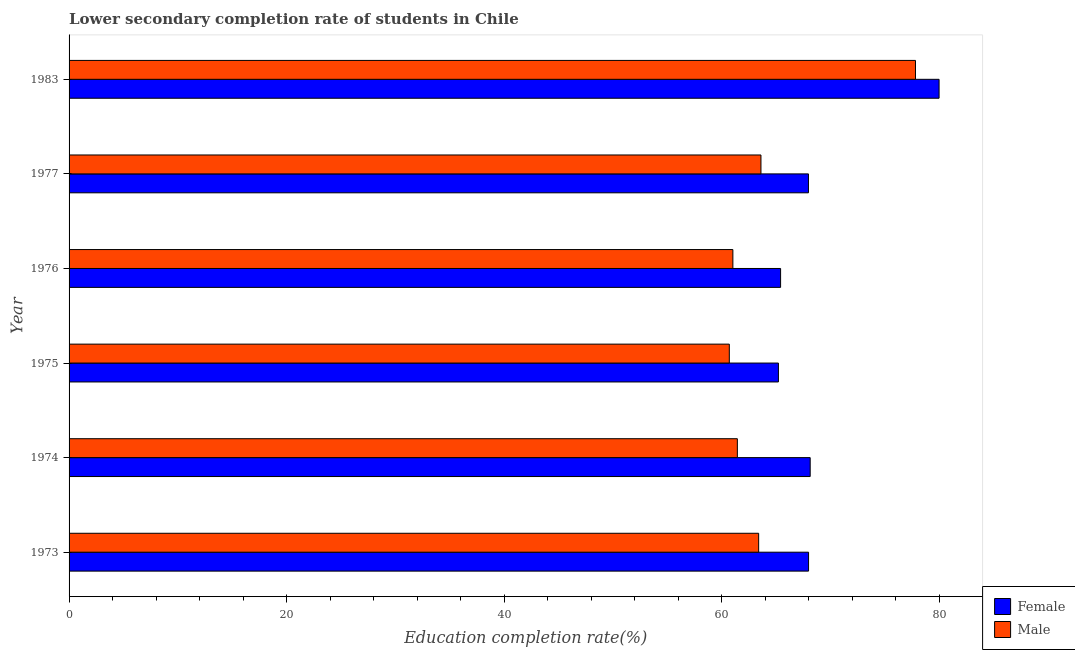Are the number of bars per tick equal to the number of legend labels?
Your answer should be compact. Yes. Are the number of bars on each tick of the Y-axis equal?
Offer a very short reply. Yes. How many bars are there on the 6th tick from the bottom?
Provide a succinct answer. 2. What is the label of the 4th group of bars from the top?
Offer a terse response. 1975. What is the education completion rate of male students in 1973?
Make the answer very short. 63.41. Across all years, what is the maximum education completion rate of male students?
Offer a terse response. 77.83. Across all years, what is the minimum education completion rate of female students?
Your answer should be very brief. 65.23. In which year was the education completion rate of female students maximum?
Offer a very short reply. 1983. In which year was the education completion rate of male students minimum?
Keep it short and to the point. 1975. What is the total education completion rate of female students in the graph?
Your answer should be compact. 414.78. What is the difference between the education completion rate of female students in 1973 and that in 1974?
Your response must be concise. -0.15. What is the difference between the education completion rate of female students in 1975 and the education completion rate of male students in 1974?
Ensure brevity in your answer.  3.78. What is the average education completion rate of male students per year?
Ensure brevity in your answer.  64.68. In the year 1975, what is the difference between the education completion rate of female students and education completion rate of male students?
Your answer should be compact. 4.52. What is the ratio of the education completion rate of female students in 1974 to that in 1976?
Your response must be concise. 1.04. Is the education completion rate of male students in 1974 less than that in 1975?
Make the answer very short. No. Is the difference between the education completion rate of female students in 1973 and 1977 greater than the difference between the education completion rate of male students in 1973 and 1977?
Make the answer very short. Yes. What is the difference between the highest and the second highest education completion rate of female students?
Provide a short and direct response. 11.85. What is the difference between the highest and the lowest education completion rate of female students?
Offer a terse response. 14.77. What does the 1st bar from the top in 1976 represents?
Offer a very short reply. Male. What does the 2nd bar from the bottom in 1976 represents?
Ensure brevity in your answer.  Male. Does the graph contain grids?
Ensure brevity in your answer.  No. Where does the legend appear in the graph?
Your answer should be compact. Bottom right. How many legend labels are there?
Make the answer very short. 2. What is the title of the graph?
Give a very brief answer. Lower secondary completion rate of students in Chile. Does "Merchandise imports" appear as one of the legend labels in the graph?
Your answer should be very brief. No. What is the label or title of the X-axis?
Offer a terse response. Education completion rate(%). What is the label or title of the Y-axis?
Your response must be concise. Year. What is the Education completion rate(%) in Female in 1973?
Your response must be concise. 68. What is the Education completion rate(%) in Male in 1973?
Your answer should be very brief. 63.41. What is the Education completion rate(%) of Female in 1974?
Give a very brief answer. 68.15. What is the Education completion rate(%) of Male in 1974?
Keep it short and to the point. 61.45. What is the Education completion rate(%) in Female in 1975?
Your answer should be very brief. 65.23. What is the Education completion rate(%) of Male in 1975?
Offer a terse response. 60.71. What is the Education completion rate(%) in Female in 1976?
Offer a terse response. 65.43. What is the Education completion rate(%) of Male in 1976?
Your answer should be compact. 61.04. What is the Education completion rate(%) of Female in 1977?
Your answer should be compact. 67.99. What is the Education completion rate(%) in Male in 1977?
Offer a very short reply. 63.62. What is the Education completion rate(%) in Female in 1983?
Offer a very short reply. 80. What is the Education completion rate(%) of Male in 1983?
Offer a terse response. 77.83. Across all years, what is the maximum Education completion rate(%) of Female?
Your answer should be compact. 80. Across all years, what is the maximum Education completion rate(%) of Male?
Ensure brevity in your answer.  77.83. Across all years, what is the minimum Education completion rate(%) of Female?
Offer a terse response. 65.23. Across all years, what is the minimum Education completion rate(%) in Male?
Provide a succinct answer. 60.71. What is the total Education completion rate(%) in Female in the graph?
Give a very brief answer. 414.78. What is the total Education completion rate(%) in Male in the graph?
Your answer should be very brief. 388.06. What is the difference between the Education completion rate(%) of Female in 1973 and that in 1974?
Offer a very short reply. -0.15. What is the difference between the Education completion rate(%) of Male in 1973 and that in 1974?
Make the answer very short. 1.96. What is the difference between the Education completion rate(%) of Female in 1973 and that in 1975?
Your answer should be very brief. 2.77. What is the difference between the Education completion rate(%) in Male in 1973 and that in 1975?
Offer a very short reply. 2.7. What is the difference between the Education completion rate(%) in Female in 1973 and that in 1976?
Your answer should be compact. 2.57. What is the difference between the Education completion rate(%) of Male in 1973 and that in 1976?
Give a very brief answer. 2.37. What is the difference between the Education completion rate(%) of Female in 1973 and that in 1977?
Keep it short and to the point. 0.01. What is the difference between the Education completion rate(%) of Male in 1973 and that in 1977?
Your answer should be compact. -0.21. What is the difference between the Education completion rate(%) of Female in 1973 and that in 1983?
Offer a terse response. -12. What is the difference between the Education completion rate(%) in Male in 1973 and that in 1983?
Provide a succinct answer. -14.42. What is the difference between the Education completion rate(%) in Female in 1974 and that in 1975?
Ensure brevity in your answer.  2.92. What is the difference between the Education completion rate(%) of Male in 1974 and that in 1975?
Keep it short and to the point. 0.74. What is the difference between the Education completion rate(%) in Female in 1974 and that in 1976?
Provide a succinct answer. 2.72. What is the difference between the Education completion rate(%) in Male in 1974 and that in 1976?
Provide a succinct answer. 0.41. What is the difference between the Education completion rate(%) in Female in 1974 and that in 1977?
Make the answer very short. 0.16. What is the difference between the Education completion rate(%) of Male in 1974 and that in 1977?
Give a very brief answer. -2.17. What is the difference between the Education completion rate(%) of Female in 1974 and that in 1983?
Ensure brevity in your answer.  -11.85. What is the difference between the Education completion rate(%) of Male in 1974 and that in 1983?
Make the answer very short. -16.38. What is the difference between the Education completion rate(%) in Female in 1975 and that in 1976?
Your response must be concise. -0.2. What is the difference between the Education completion rate(%) of Male in 1975 and that in 1976?
Make the answer very short. -0.33. What is the difference between the Education completion rate(%) in Female in 1975 and that in 1977?
Your response must be concise. -2.76. What is the difference between the Education completion rate(%) in Male in 1975 and that in 1977?
Your response must be concise. -2.91. What is the difference between the Education completion rate(%) of Female in 1975 and that in 1983?
Offer a very short reply. -14.77. What is the difference between the Education completion rate(%) of Male in 1975 and that in 1983?
Ensure brevity in your answer.  -17.12. What is the difference between the Education completion rate(%) in Female in 1976 and that in 1977?
Your answer should be compact. -2.56. What is the difference between the Education completion rate(%) in Male in 1976 and that in 1977?
Keep it short and to the point. -2.58. What is the difference between the Education completion rate(%) in Female in 1976 and that in 1983?
Your response must be concise. -14.57. What is the difference between the Education completion rate(%) in Male in 1976 and that in 1983?
Your response must be concise. -16.79. What is the difference between the Education completion rate(%) of Female in 1977 and that in 1983?
Provide a succinct answer. -12.01. What is the difference between the Education completion rate(%) in Male in 1977 and that in 1983?
Offer a very short reply. -14.21. What is the difference between the Education completion rate(%) of Female in 1973 and the Education completion rate(%) of Male in 1974?
Provide a succinct answer. 6.55. What is the difference between the Education completion rate(%) in Female in 1973 and the Education completion rate(%) in Male in 1975?
Your answer should be compact. 7.29. What is the difference between the Education completion rate(%) in Female in 1973 and the Education completion rate(%) in Male in 1976?
Your answer should be compact. 6.96. What is the difference between the Education completion rate(%) in Female in 1973 and the Education completion rate(%) in Male in 1977?
Your answer should be very brief. 4.38. What is the difference between the Education completion rate(%) in Female in 1973 and the Education completion rate(%) in Male in 1983?
Your answer should be very brief. -9.83. What is the difference between the Education completion rate(%) in Female in 1974 and the Education completion rate(%) in Male in 1975?
Make the answer very short. 7.44. What is the difference between the Education completion rate(%) of Female in 1974 and the Education completion rate(%) of Male in 1976?
Your answer should be compact. 7.11. What is the difference between the Education completion rate(%) in Female in 1974 and the Education completion rate(%) in Male in 1977?
Your response must be concise. 4.53. What is the difference between the Education completion rate(%) in Female in 1974 and the Education completion rate(%) in Male in 1983?
Make the answer very short. -9.68. What is the difference between the Education completion rate(%) in Female in 1975 and the Education completion rate(%) in Male in 1976?
Ensure brevity in your answer.  4.19. What is the difference between the Education completion rate(%) in Female in 1975 and the Education completion rate(%) in Male in 1977?
Keep it short and to the point. 1.61. What is the difference between the Education completion rate(%) of Female in 1975 and the Education completion rate(%) of Male in 1983?
Offer a terse response. -12.6. What is the difference between the Education completion rate(%) in Female in 1976 and the Education completion rate(%) in Male in 1977?
Offer a very short reply. 1.81. What is the difference between the Education completion rate(%) of Female in 1976 and the Education completion rate(%) of Male in 1983?
Offer a terse response. -12.4. What is the difference between the Education completion rate(%) of Female in 1977 and the Education completion rate(%) of Male in 1983?
Ensure brevity in your answer.  -9.84. What is the average Education completion rate(%) of Female per year?
Offer a very short reply. 69.13. What is the average Education completion rate(%) in Male per year?
Offer a very short reply. 64.68. In the year 1973, what is the difference between the Education completion rate(%) in Female and Education completion rate(%) in Male?
Offer a very short reply. 4.59. In the year 1974, what is the difference between the Education completion rate(%) in Female and Education completion rate(%) in Male?
Your answer should be very brief. 6.7. In the year 1975, what is the difference between the Education completion rate(%) of Female and Education completion rate(%) of Male?
Your answer should be compact. 4.52. In the year 1976, what is the difference between the Education completion rate(%) of Female and Education completion rate(%) of Male?
Your response must be concise. 4.39. In the year 1977, what is the difference between the Education completion rate(%) in Female and Education completion rate(%) in Male?
Ensure brevity in your answer.  4.37. In the year 1983, what is the difference between the Education completion rate(%) of Female and Education completion rate(%) of Male?
Ensure brevity in your answer.  2.17. What is the ratio of the Education completion rate(%) in Female in 1973 to that in 1974?
Give a very brief answer. 1. What is the ratio of the Education completion rate(%) in Male in 1973 to that in 1974?
Provide a succinct answer. 1.03. What is the ratio of the Education completion rate(%) in Female in 1973 to that in 1975?
Offer a terse response. 1.04. What is the ratio of the Education completion rate(%) of Male in 1973 to that in 1975?
Offer a terse response. 1.04. What is the ratio of the Education completion rate(%) of Female in 1973 to that in 1976?
Offer a terse response. 1.04. What is the ratio of the Education completion rate(%) in Male in 1973 to that in 1976?
Offer a terse response. 1.04. What is the ratio of the Education completion rate(%) of Female in 1973 to that in 1977?
Your answer should be compact. 1. What is the ratio of the Education completion rate(%) of Male in 1973 to that in 1983?
Keep it short and to the point. 0.81. What is the ratio of the Education completion rate(%) of Female in 1974 to that in 1975?
Your response must be concise. 1.04. What is the ratio of the Education completion rate(%) in Male in 1974 to that in 1975?
Your answer should be compact. 1.01. What is the ratio of the Education completion rate(%) in Female in 1974 to that in 1976?
Provide a succinct answer. 1.04. What is the ratio of the Education completion rate(%) of Male in 1974 to that in 1976?
Provide a succinct answer. 1.01. What is the ratio of the Education completion rate(%) of Male in 1974 to that in 1977?
Keep it short and to the point. 0.97. What is the ratio of the Education completion rate(%) in Female in 1974 to that in 1983?
Your answer should be very brief. 0.85. What is the ratio of the Education completion rate(%) in Male in 1974 to that in 1983?
Keep it short and to the point. 0.79. What is the ratio of the Education completion rate(%) in Female in 1975 to that in 1977?
Make the answer very short. 0.96. What is the ratio of the Education completion rate(%) of Male in 1975 to that in 1977?
Provide a short and direct response. 0.95. What is the ratio of the Education completion rate(%) of Female in 1975 to that in 1983?
Ensure brevity in your answer.  0.82. What is the ratio of the Education completion rate(%) in Male in 1975 to that in 1983?
Offer a very short reply. 0.78. What is the ratio of the Education completion rate(%) in Female in 1976 to that in 1977?
Make the answer very short. 0.96. What is the ratio of the Education completion rate(%) of Male in 1976 to that in 1977?
Provide a short and direct response. 0.96. What is the ratio of the Education completion rate(%) in Female in 1976 to that in 1983?
Offer a very short reply. 0.82. What is the ratio of the Education completion rate(%) of Male in 1976 to that in 1983?
Give a very brief answer. 0.78. What is the ratio of the Education completion rate(%) in Female in 1977 to that in 1983?
Your answer should be very brief. 0.85. What is the ratio of the Education completion rate(%) in Male in 1977 to that in 1983?
Offer a very short reply. 0.82. What is the difference between the highest and the second highest Education completion rate(%) in Female?
Provide a succinct answer. 11.85. What is the difference between the highest and the second highest Education completion rate(%) in Male?
Make the answer very short. 14.21. What is the difference between the highest and the lowest Education completion rate(%) of Female?
Offer a terse response. 14.77. What is the difference between the highest and the lowest Education completion rate(%) of Male?
Your answer should be very brief. 17.12. 